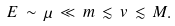Convert formula to latex. <formula><loc_0><loc_0><loc_500><loc_500>E \, \sim \, \mu \, \ll \, m \, \lesssim \, v \, \lesssim \, M .</formula> 